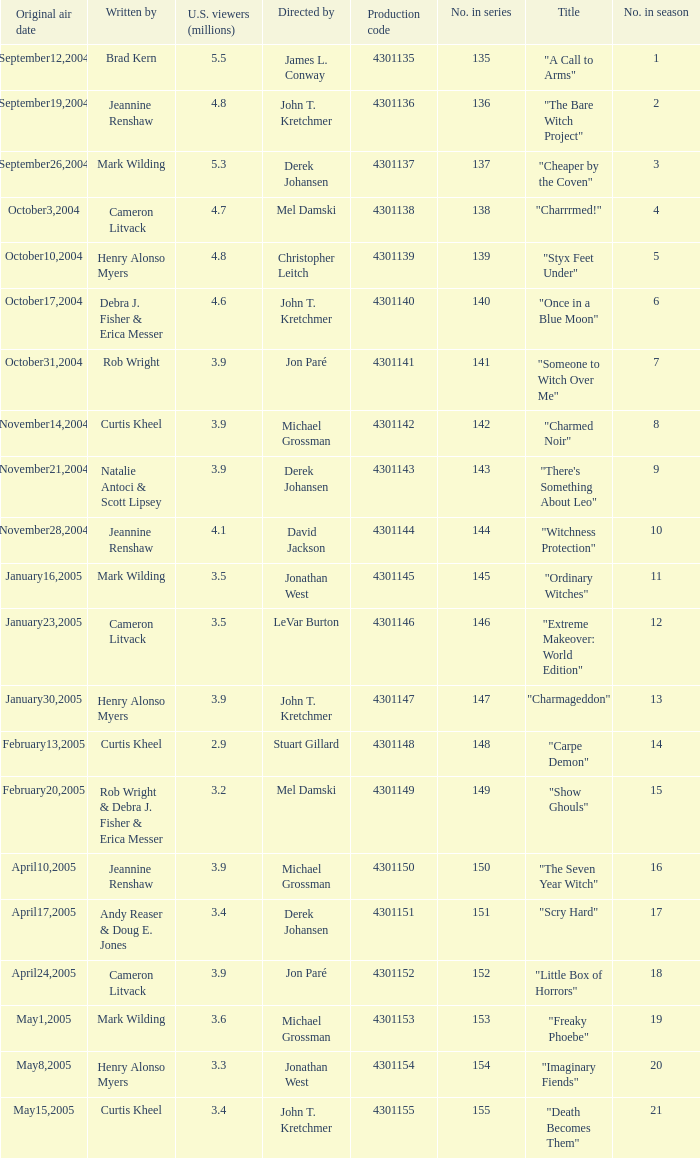Parse the full table. {'header': ['Original air date', 'Written by', 'U.S. viewers (millions)', 'Directed by', 'Production code', 'No. in series', 'Title', 'No. in season'], 'rows': [['September12,2004', 'Brad Kern', '5.5', 'James L. Conway', '4301135', '135', '"A Call to Arms"', '1'], ['September19,2004', 'Jeannine Renshaw', '4.8', 'John T. Kretchmer', '4301136', '136', '"The Bare Witch Project"', '2'], ['September26,2004', 'Mark Wilding', '5.3', 'Derek Johansen', '4301137', '137', '"Cheaper by the Coven"', '3'], ['October3,2004', 'Cameron Litvack', '4.7', 'Mel Damski', '4301138', '138', '"Charrrmed!"', '4'], ['October10,2004', 'Henry Alonso Myers', '4.8', 'Christopher Leitch', '4301139', '139', '"Styx Feet Under"', '5'], ['October17,2004', 'Debra J. Fisher & Erica Messer', '4.6', 'John T. Kretchmer', '4301140', '140', '"Once in a Blue Moon"', '6'], ['October31,2004', 'Rob Wright', '3.9', 'Jon Paré', '4301141', '141', '"Someone to Witch Over Me"', '7'], ['November14,2004', 'Curtis Kheel', '3.9', 'Michael Grossman', '4301142', '142', '"Charmed Noir"', '8'], ['November21,2004', 'Natalie Antoci & Scott Lipsey', '3.9', 'Derek Johansen', '4301143', '143', '"There\'s Something About Leo"', '9'], ['November28,2004', 'Jeannine Renshaw', '4.1', 'David Jackson', '4301144', '144', '"Witchness Protection"', '10'], ['January16,2005', 'Mark Wilding', '3.5', 'Jonathan West', '4301145', '145', '"Ordinary Witches"', '11'], ['January23,2005', 'Cameron Litvack', '3.5', 'LeVar Burton', '4301146', '146', '"Extreme Makeover: World Edition"', '12'], ['January30,2005', 'Henry Alonso Myers', '3.9', 'John T. Kretchmer', '4301147', '147', '"Charmageddon"', '13'], ['February13,2005', 'Curtis Kheel', '2.9', 'Stuart Gillard', '4301148', '148', '"Carpe Demon"', '14'], ['February20,2005', 'Rob Wright & Debra J. Fisher & Erica Messer', '3.2', 'Mel Damski', '4301149', '149', '"Show Ghouls"', '15'], ['April10,2005', 'Jeannine Renshaw', '3.9', 'Michael Grossman', '4301150', '150', '"The Seven Year Witch"', '16'], ['April17,2005', 'Andy Reaser & Doug E. Jones', '3.4', 'Derek Johansen', '4301151', '151', '"Scry Hard"', '17'], ['April24,2005', 'Cameron Litvack', '3.9', 'Jon Paré', '4301152', '152', '"Little Box of Horrors"', '18'], ['May1,2005', 'Mark Wilding', '3.6', 'Michael Grossman', '4301153', '153', '"Freaky Phoebe"', '19'], ['May8,2005', 'Henry Alonso Myers', '3.3', 'Jonathan West', '4301154', '154', '"Imaginary Fiends"', '20'], ['May15,2005', 'Curtis Kheel', '3.4', 'John T. Kretchmer', '4301155', '155', '"Death Becomes Them"', '21']]} What was the name of the episode that got 3.3 (millions) of u.s viewers? "Imaginary Fiends". 